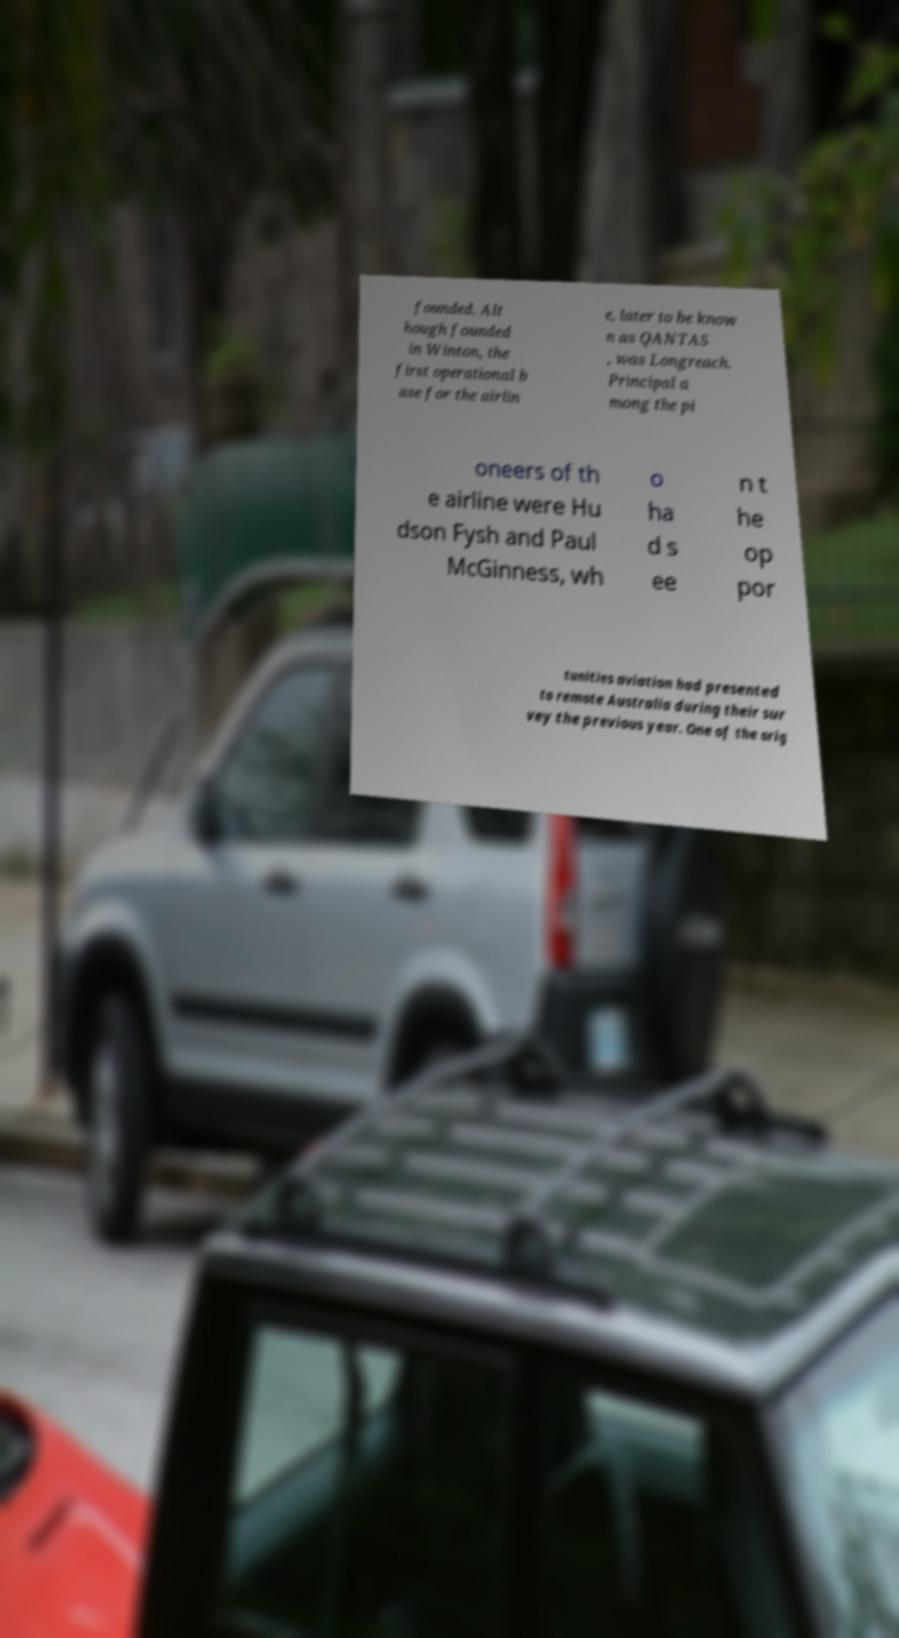There's text embedded in this image that I need extracted. Can you transcribe it verbatim? founded. Alt hough founded in Winton, the first operational b ase for the airlin e, later to be know n as QANTAS , was Longreach. Principal a mong the pi oneers of th e airline were Hu dson Fysh and Paul McGinness, wh o ha d s ee n t he op por tunities aviation had presented to remote Australia during their sur vey the previous year. One of the orig 